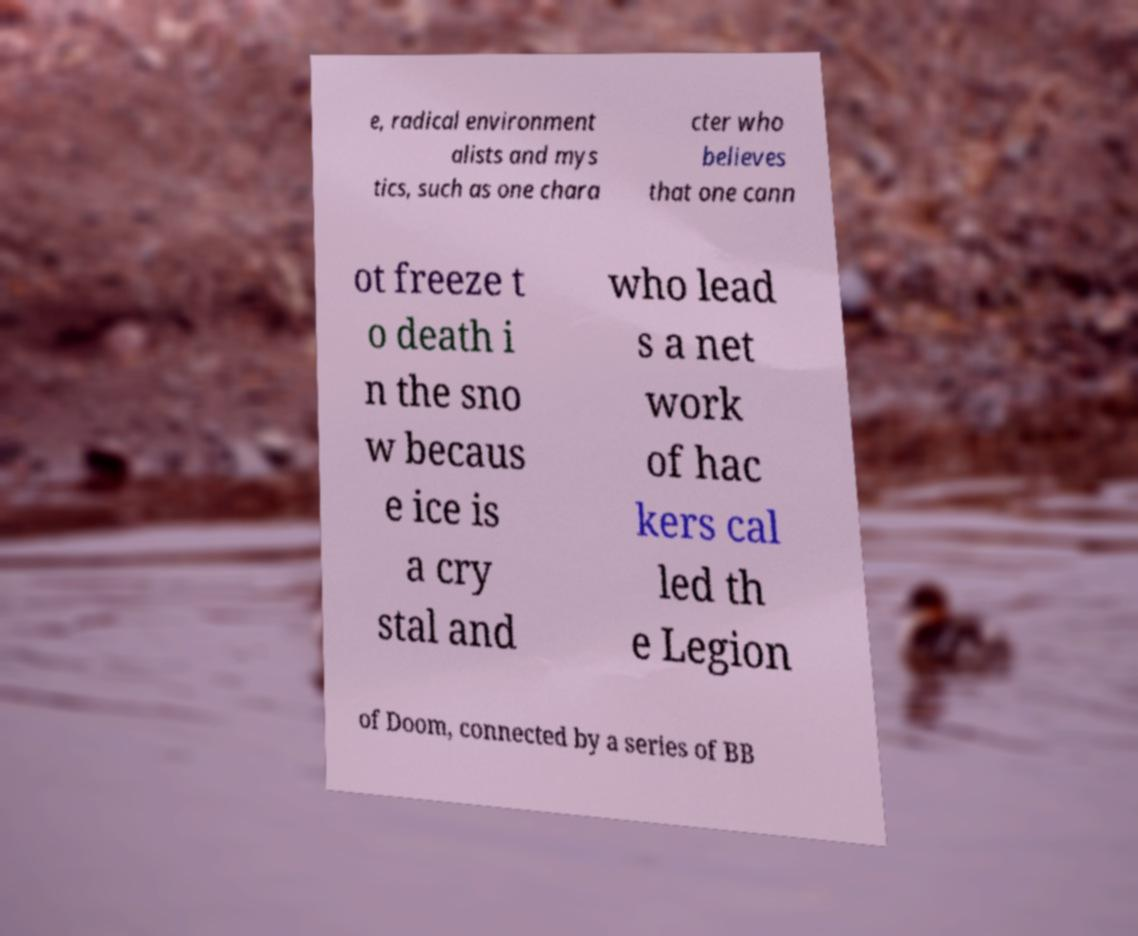What messages or text are displayed in this image? I need them in a readable, typed format. e, radical environment alists and mys tics, such as one chara cter who believes that one cann ot freeze t o death i n the sno w becaus e ice is a cry stal and who lead s a net work of hac kers cal led th e Legion of Doom, connected by a series of BB 